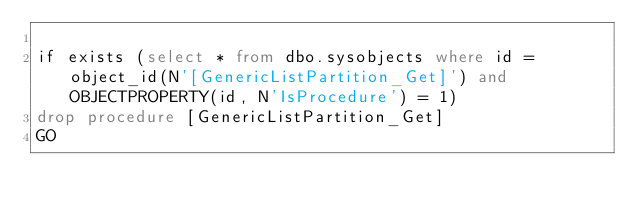Convert code to text. <code><loc_0><loc_0><loc_500><loc_500><_SQL_>
if exists (select * from dbo.sysobjects where id = object_id(N'[GenericListPartition_Get]') and OBJECTPROPERTY(id, N'IsProcedure') = 1)
drop procedure [GenericListPartition_Get]
GO


</code> 